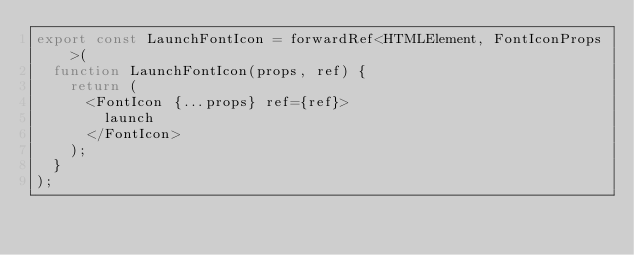Convert code to text. <code><loc_0><loc_0><loc_500><loc_500><_TypeScript_>export const LaunchFontIcon = forwardRef<HTMLElement, FontIconProps>(
  function LaunchFontIcon(props, ref) {
    return (
      <FontIcon {...props} ref={ref}>
        launch
      </FontIcon>
    );
  }
);
</code> 